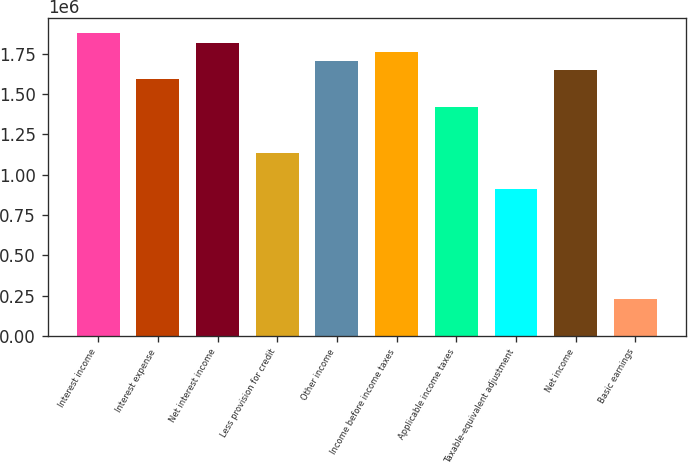<chart> <loc_0><loc_0><loc_500><loc_500><bar_chart><fcel>Interest income<fcel>Interest expense<fcel>Net interest income<fcel>Less provision for credit<fcel>Other income<fcel>Income before income taxes<fcel>Applicable income taxes<fcel>Taxable-equivalent adjustment<fcel>Net income<fcel>Basic earnings<nl><fcel>1.87545e+06<fcel>1.59129e+06<fcel>1.81862e+06<fcel>1.13664e+06<fcel>1.70496e+06<fcel>1.76179e+06<fcel>1.4208e+06<fcel>909310<fcel>1.64812e+06<fcel>227328<nl></chart> 